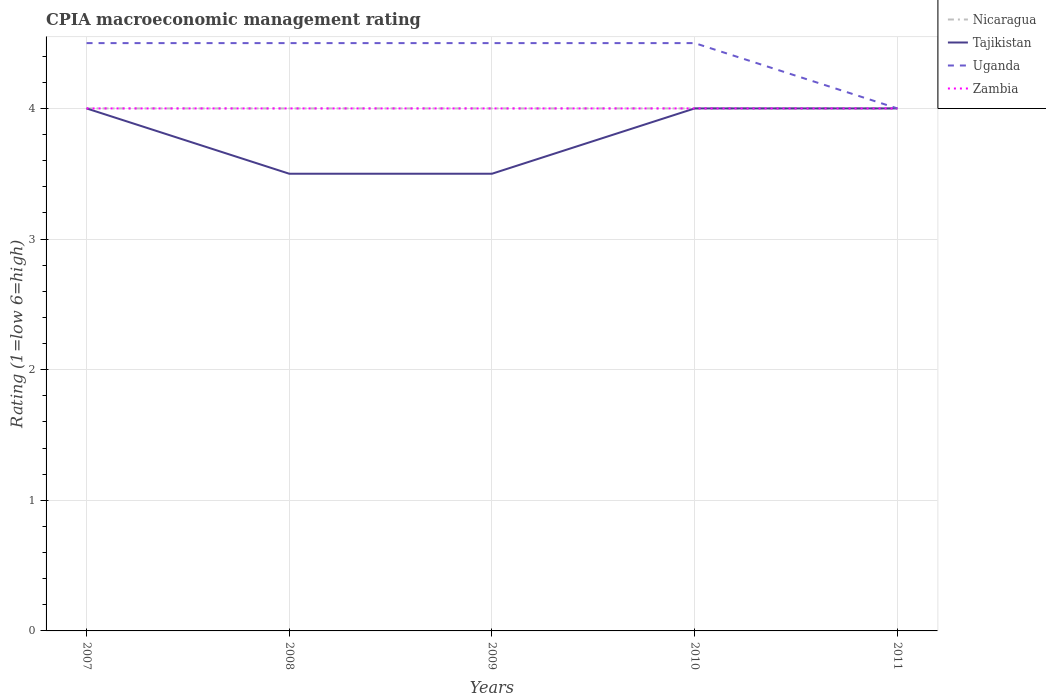Across all years, what is the maximum CPIA rating in Uganda?
Your answer should be compact. 4. In which year was the CPIA rating in Uganda maximum?
Your answer should be compact. 2011. What is the difference between the highest and the second highest CPIA rating in Tajikistan?
Your response must be concise. 0.5. What is the difference between the highest and the lowest CPIA rating in Tajikistan?
Provide a short and direct response. 3. How many years are there in the graph?
Make the answer very short. 5. What is the difference between two consecutive major ticks on the Y-axis?
Make the answer very short. 1. Does the graph contain grids?
Your response must be concise. Yes. Where does the legend appear in the graph?
Offer a terse response. Top right. What is the title of the graph?
Make the answer very short. CPIA macroeconomic management rating. What is the label or title of the X-axis?
Offer a terse response. Years. What is the Rating (1=low 6=high) of Nicaragua in 2007?
Offer a terse response. 4. What is the Rating (1=low 6=high) of Tajikistan in 2007?
Give a very brief answer. 4. What is the Rating (1=low 6=high) of Zambia in 2007?
Offer a very short reply. 4. What is the Rating (1=low 6=high) in Nicaragua in 2008?
Your answer should be very brief. 4. What is the Rating (1=low 6=high) of Tajikistan in 2008?
Provide a succinct answer. 3.5. What is the Rating (1=low 6=high) of Uganda in 2008?
Your response must be concise. 4.5. What is the Rating (1=low 6=high) in Zambia in 2008?
Give a very brief answer. 4. What is the Rating (1=low 6=high) in Tajikistan in 2009?
Ensure brevity in your answer.  3.5. What is the Rating (1=low 6=high) of Nicaragua in 2010?
Your response must be concise. 4. What is the Rating (1=low 6=high) of Uganda in 2010?
Ensure brevity in your answer.  4.5. What is the Rating (1=low 6=high) of Zambia in 2010?
Provide a succinct answer. 4. What is the Rating (1=low 6=high) of Zambia in 2011?
Give a very brief answer. 4. Across all years, what is the maximum Rating (1=low 6=high) in Nicaragua?
Provide a succinct answer. 4. Across all years, what is the maximum Rating (1=low 6=high) of Tajikistan?
Your answer should be very brief. 4. Across all years, what is the minimum Rating (1=low 6=high) of Nicaragua?
Offer a very short reply. 4. Across all years, what is the minimum Rating (1=low 6=high) in Tajikistan?
Ensure brevity in your answer.  3.5. Across all years, what is the minimum Rating (1=low 6=high) of Uganda?
Keep it short and to the point. 4. Across all years, what is the minimum Rating (1=low 6=high) in Zambia?
Offer a terse response. 4. What is the total Rating (1=low 6=high) in Nicaragua in the graph?
Your answer should be compact. 20. What is the total Rating (1=low 6=high) of Uganda in the graph?
Make the answer very short. 22. What is the difference between the Rating (1=low 6=high) in Nicaragua in 2007 and that in 2008?
Your response must be concise. 0. What is the difference between the Rating (1=low 6=high) in Tajikistan in 2007 and that in 2008?
Offer a terse response. 0.5. What is the difference between the Rating (1=low 6=high) of Uganda in 2007 and that in 2008?
Ensure brevity in your answer.  0. What is the difference between the Rating (1=low 6=high) of Tajikistan in 2007 and that in 2009?
Keep it short and to the point. 0.5. What is the difference between the Rating (1=low 6=high) of Uganda in 2007 and that in 2009?
Your answer should be very brief. 0. What is the difference between the Rating (1=low 6=high) in Zambia in 2007 and that in 2009?
Offer a very short reply. 0. What is the difference between the Rating (1=low 6=high) in Nicaragua in 2007 and that in 2010?
Provide a succinct answer. 0. What is the difference between the Rating (1=low 6=high) in Uganda in 2007 and that in 2011?
Ensure brevity in your answer.  0.5. What is the difference between the Rating (1=low 6=high) in Tajikistan in 2008 and that in 2009?
Provide a succinct answer. 0. What is the difference between the Rating (1=low 6=high) in Uganda in 2008 and that in 2009?
Provide a succinct answer. 0. What is the difference between the Rating (1=low 6=high) in Uganda in 2008 and that in 2010?
Offer a terse response. 0. What is the difference between the Rating (1=low 6=high) in Zambia in 2008 and that in 2011?
Provide a succinct answer. 0. What is the difference between the Rating (1=low 6=high) in Nicaragua in 2009 and that in 2010?
Ensure brevity in your answer.  0. What is the difference between the Rating (1=low 6=high) in Zambia in 2009 and that in 2010?
Offer a very short reply. 0. What is the difference between the Rating (1=low 6=high) of Nicaragua in 2009 and that in 2011?
Your answer should be compact. 0. What is the difference between the Rating (1=low 6=high) of Tajikistan in 2009 and that in 2011?
Keep it short and to the point. -0.5. What is the difference between the Rating (1=low 6=high) of Uganda in 2009 and that in 2011?
Offer a terse response. 0.5. What is the difference between the Rating (1=low 6=high) of Zambia in 2009 and that in 2011?
Make the answer very short. 0. What is the difference between the Rating (1=low 6=high) in Tajikistan in 2010 and that in 2011?
Offer a very short reply. 0. What is the difference between the Rating (1=low 6=high) in Nicaragua in 2007 and the Rating (1=low 6=high) in Tajikistan in 2008?
Your answer should be very brief. 0.5. What is the difference between the Rating (1=low 6=high) of Tajikistan in 2007 and the Rating (1=low 6=high) of Uganda in 2008?
Ensure brevity in your answer.  -0.5. What is the difference between the Rating (1=low 6=high) in Uganda in 2007 and the Rating (1=low 6=high) in Zambia in 2008?
Your answer should be compact. 0.5. What is the difference between the Rating (1=low 6=high) in Nicaragua in 2007 and the Rating (1=low 6=high) in Tajikistan in 2009?
Make the answer very short. 0.5. What is the difference between the Rating (1=low 6=high) of Nicaragua in 2007 and the Rating (1=low 6=high) of Zambia in 2009?
Your answer should be very brief. 0. What is the difference between the Rating (1=low 6=high) in Tajikistan in 2007 and the Rating (1=low 6=high) in Uganda in 2009?
Offer a terse response. -0.5. What is the difference between the Rating (1=low 6=high) in Tajikistan in 2007 and the Rating (1=low 6=high) in Zambia in 2009?
Offer a very short reply. 0. What is the difference between the Rating (1=low 6=high) in Uganda in 2007 and the Rating (1=low 6=high) in Zambia in 2009?
Your answer should be compact. 0.5. What is the difference between the Rating (1=low 6=high) in Nicaragua in 2007 and the Rating (1=low 6=high) in Uganda in 2010?
Your answer should be compact. -0.5. What is the difference between the Rating (1=low 6=high) of Tajikistan in 2007 and the Rating (1=low 6=high) of Uganda in 2010?
Your response must be concise. -0.5. What is the difference between the Rating (1=low 6=high) in Tajikistan in 2007 and the Rating (1=low 6=high) in Zambia in 2010?
Keep it short and to the point. 0. What is the difference between the Rating (1=low 6=high) in Uganda in 2007 and the Rating (1=low 6=high) in Zambia in 2010?
Your answer should be compact. 0.5. What is the difference between the Rating (1=low 6=high) of Tajikistan in 2007 and the Rating (1=low 6=high) of Uganda in 2011?
Your answer should be very brief. 0. What is the difference between the Rating (1=low 6=high) of Tajikistan in 2007 and the Rating (1=low 6=high) of Zambia in 2011?
Keep it short and to the point. 0. What is the difference between the Rating (1=low 6=high) in Tajikistan in 2008 and the Rating (1=low 6=high) in Zambia in 2009?
Your answer should be very brief. -0.5. What is the difference between the Rating (1=low 6=high) in Uganda in 2008 and the Rating (1=low 6=high) in Zambia in 2009?
Offer a terse response. 0.5. What is the difference between the Rating (1=low 6=high) in Nicaragua in 2008 and the Rating (1=low 6=high) in Tajikistan in 2010?
Ensure brevity in your answer.  0. What is the difference between the Rating (1=low 6=high) in Uganda in 2008 and the Rating (1=low 6=high) in Zambia in 2010?
Offer a terse response. 0.5. What is the difference between the Rating (1=low 6=high) in Nicaragua in 2008 and the Rating (1=low 6=high) in Zambia in 2011?
Give a very brief answer. 0. What is the difference between the Rating (1=low 6=high) in Tajikistan in 2008 and the Rating (1=low 6=high) in Zambia in 2011?
Make the answer very short. -0.5. What is the difference between the Rating (1=low 6=high) in Nicaragua in 2009 and the Rating (1=low 6=high) in Zambia in 2011?
Offer a terse response. 0. What is the average Rating (1=low 6=high) in Nicaragua per year?
Offer a very short reply. 4. What is the average Rating (1=low 6=high) in Tajikistan per year?
Your answer should be very brief. 3.8. In the year 2007, what is the difference between the Rating (1=low 6=high) of Uganda and Rating (1=low 6=high) of Zambia?
Provide a short and direct response. 0.5. In the year 2008, what is the difference between the Rating (1=low 6=high) of Nicaragua and Rating (1=low 6=high) of Zambia?
Ensure brevity in your answer.  0. In the year 2009, what is the difference between the Rating (1=low 6=high) of Nicaragua and Rating (1=low 6=high) of Tajikistan?
Ensure brevity in your answer.  0.5. In the year 2009, what is the difference between the Rating (1=low 6=high) in Tajikistan and Rating (1=low 6=high) in Zambia?
Your answer should be compact. -0.5. In the year 2009, what is the difference between the Rating (1=low 6=high) of Uganda and Rating (1=low 6=high) of Zambia?
Make the answer very short. 0.5. In the year 2010, what is the difference between the Rating (1=low 6=high) in Nicaragua and Rating (1=low 6=high) in Tajikistan?
Provide a short and direct response. 0. In the year 2010, what is the difference between the Rating (1=low 6=high) in Nicaragua and Rating (1=low 6=high) in Zambia?
Provide a short and direct response. 0. In the year 2011, what is the difference between the Rating (1=low 6=high) of Nicaragua and Rating (1=low 6=high) of Tajikistan?
Provide a short and direct response. 0. What is the ratio of the Rating (1=low 6=high) of Tajikistan in 2007 to that in 2009?
Give a very brief answer. 1.14. What is the ratio of the Rating (1=low 6=high) of Nicaragua in 2007 to that in 2010?
Give a very brief answer. 1. What is the ratio of the Rating (1=low 6=high) of Zambia in 2007 to that in 2010?
Ensure brevity in your answer.  1. What is the ratio of the Rating (1=low 6=high) of Nicaragua in 2007 to that in 2011?
Ensure brevity in your answer.  1. What is the ratio of the Rating (1=low 6=high) of Tajikistan in 2007 to that in 2011?
Provide a short and direct response. 1. What is the ratio of the Rating (1=low 6=high) of Nicaragua in 2008 to that in 2009?
Provide a succinct answer. 1. What is the ratio of the Rating (1=low 6=high) of Tajikistan in 2008 to that in 2009?
Ensure brevity in your answer.  1. What is the ratio of the Rating (1=low 6=high) of Uganda in 2008 to that in 2010?
Ensure brevity in your answer.  1. What is the ratio of the Rating (1=low 6=high) in Zambia in 2008 to that in 2010?
Offer a very short reply. 1. What is the ratio of the Rating (1=low 6=high) in Uganda in 2008 to that in 2011?
Keep it short and to the point. 1.12. What is the ratio of the Rating (1=low 6=high) of Nicaragua in 2009 to that in 2010?
Your response must be concise. 1. What is the ratio of the Rating (1=low 6=high) of Tajikistan in 2009 to that in 2010?
Your response must be concise. 0.88. What is the ratio of the Rating (1=low 6=high) in Uganda in 2009 to that in 2010?
Offer a terse response. 1. What is the ratio of the Rating (1=low 6=high) of Uganda in 2009 to that in 2011?
Your answer should be very brief. 1.12. What is the ratio of the Rating (1=low 6=high) in Nicaragua in 2010 to that in 2011?
Your answer should be compact. 1. What is the ratio of the Rating (1=low 6=high) in Tajikistan in 2010 to that in 2011?
Offer a very short reply. 1. What is the ratio of the Rating (1=low 6=high) in Uganda in 2010 to that in 2011?
Your response must be concise. 1.12. What is the difference between the highest and the second highest Rating (1=low 6=high) in Nicaragua?
Give a very brief answer. 0. What is the difference between the highest and the second highest Rating (1=low 6=high) of Uganda?
Offer a terse response. 0. What is the difference between the highest and the lowest Rating (1=low 6=high) of Nicaragua?
Make the answer very short. 0. What is the difference between the highest and the lowest Rating (1=low 6=high) in Tajikistan?
Offer a terse response. 0.5. 